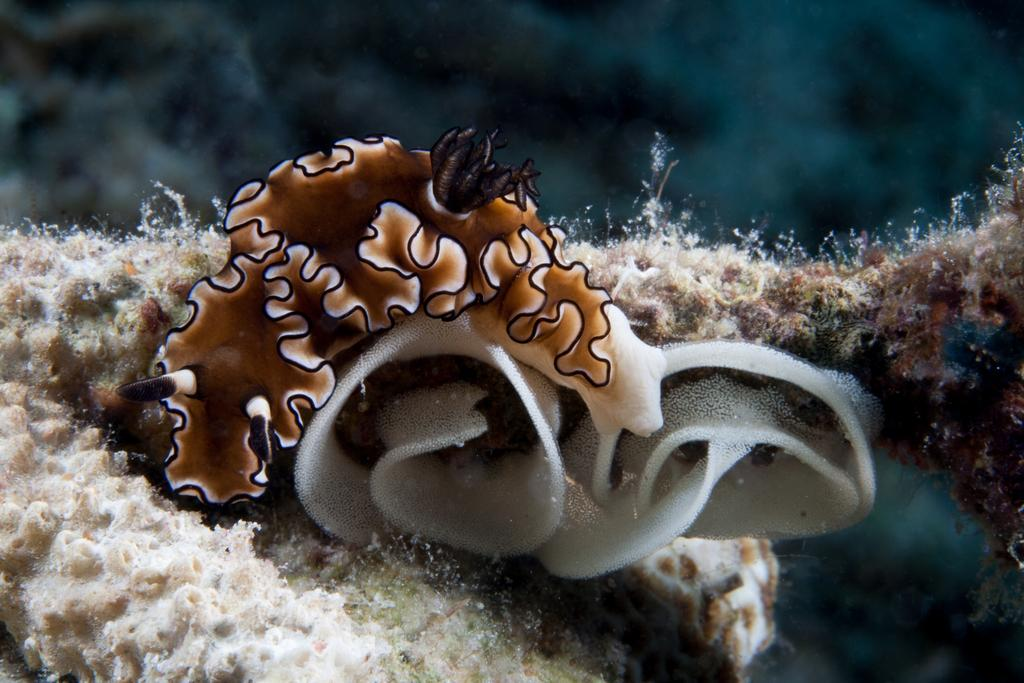What is the main subject of the image? There is a marine animal in the center of the image. Where was the image taken? The image is taken underwater. What type of car can be seen driving on the surface above the marine animal in the image? There is no car visible in the image, as it was taken underwater and does not show any surface activity. 